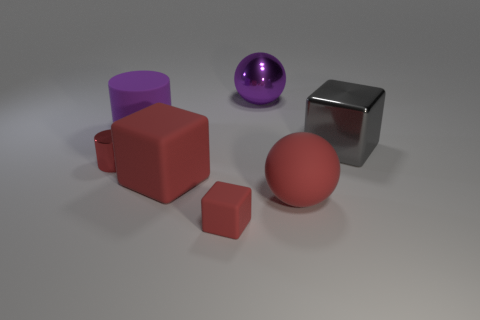Add 1 rubber balls. How many objects exist? 8 Subtract all spheres. How many objects are left? 5 Subtract all rubber cylinders. Subtract all big red cubes. How many objects are left? 5 Add 3 small objects. How many small objects are left? 5 Add 7 big gray cylinders. How many big gray cylinders exist? 7 Subtract 0 brown cylinders. How many objects are left? 7 